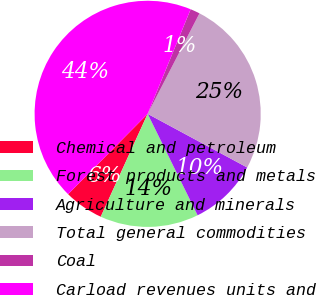Convert chart. <chart><loc_0><loc_0><loc_500><loc_500><pie_chart><fcel>Chemical and petroleum<fcel>Forest products and metals<fcel>Agriculture and minerals<fcel>Total general commodities<fcel>Coal<fcel>Carload revenues units and<nl><fcel>5.61%<fcel>14.09%<fcel>9.85%<fcel>25.29%<fcel>1.37%<fcel>43.79%<nl></chart> 